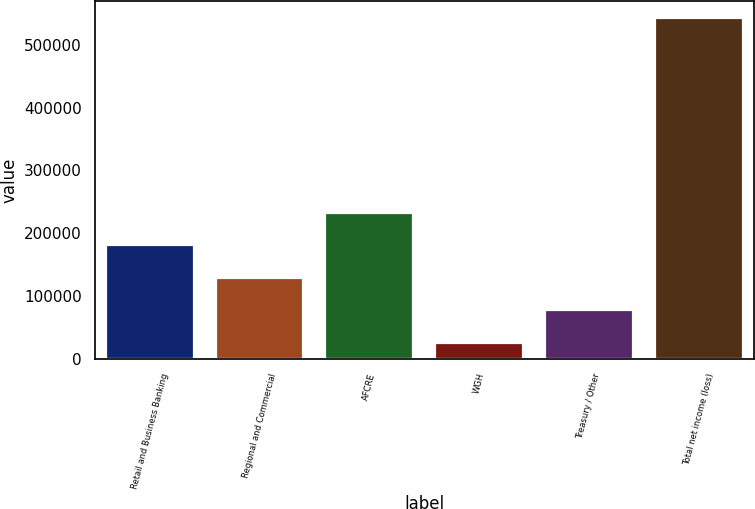Convert chart to OTSL. <chart><loc_0><loc_0><loc_500><loc_500><bar_chart><fcel>Retail and Business Banking<fcel>Regional and Commercial<fcel>AFCRE<fcel>WGH<fcel>Treasury / Other<fcel>Total net income (loss)<nl><fcel>180902<fcel>129229<fcel>232575<fcel>25883<fcel>77556<fcel>542613<nl></chart> 